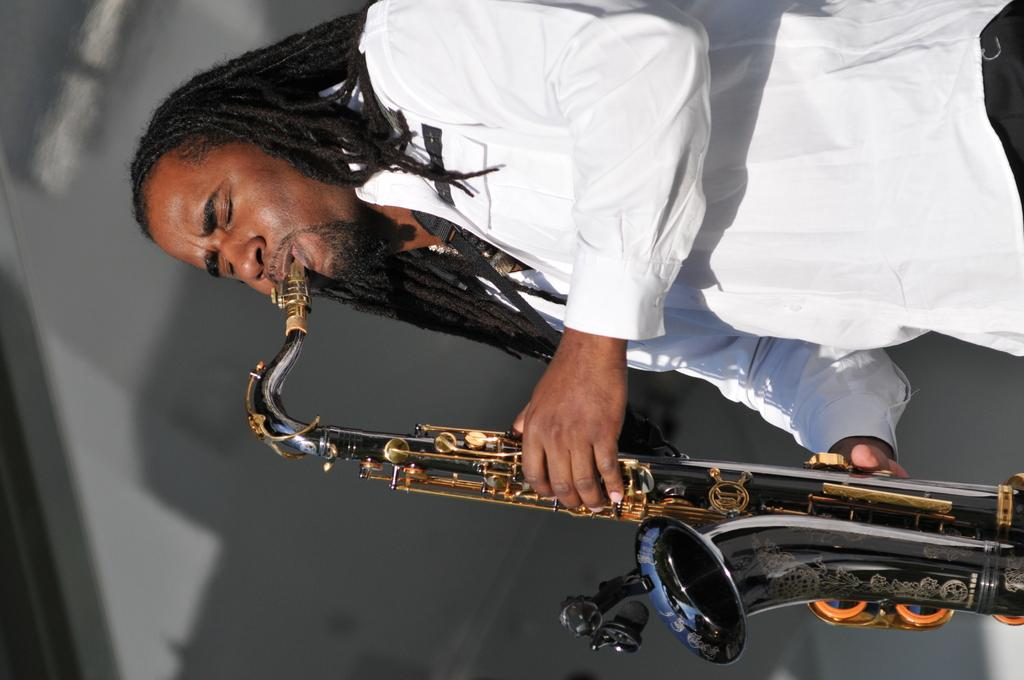What is the main subject in the foreground of the image? There is a man in the foreground of the image. What is the man wearing? The man is wearing a white shirt. What is the man doing in the image? The man appears to be playing the saxophone. What can be seen in the background of the image? There are objects in the background of the image. Can you tell me how many ducks are swimming in the background of the image? There are no ducks present in the image; it features a man playing the saxophone in the foreground and objects in the background. What type of story is being told by the man in the image? There is no story being told by the man in the image; he is simply playing the saxophone. 